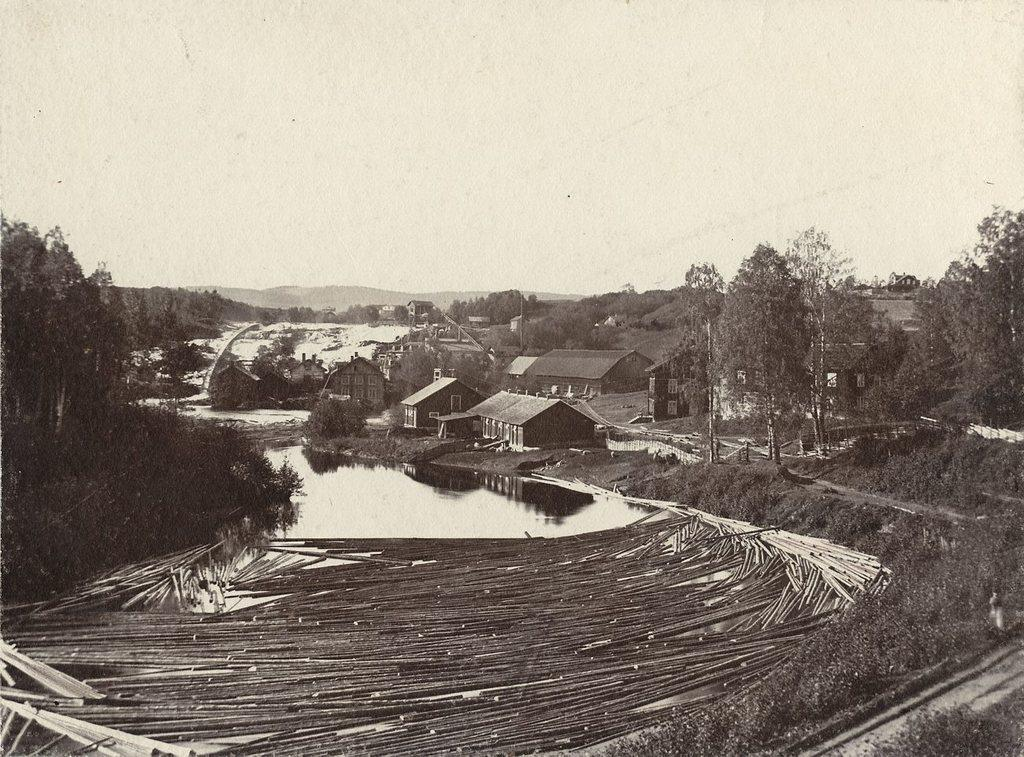What type of structures can be seen in the picture? There are houses in the picture. What type of natural elements are present in the picture? There are trees and water visible in the picture. What other objects can be seen in the picture? There are other objects in the picture, but their specific details are not mentioned in the facts. What is visible in the background of the picture? There are mountains and the sky visible in the background of the picture. What is the color scheme of the picture? The picture is black and white in color. What is the weight of the wool in the picture? There is no wool present in the picture, so it is not possible to determine its weight. 